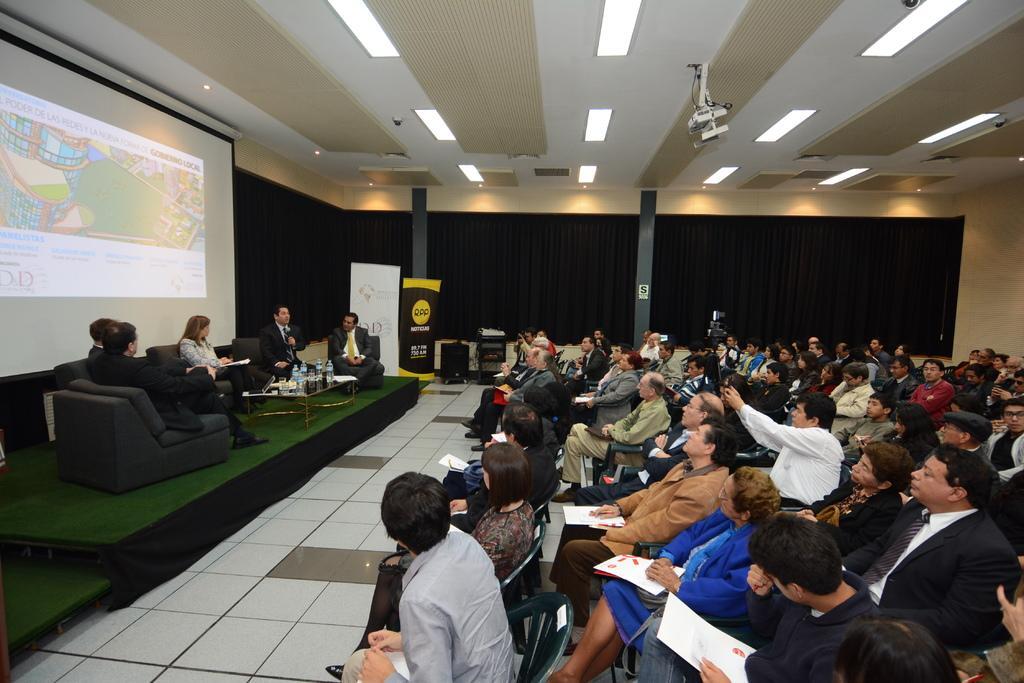Could you give a brief overview of what you see in this image? In this image people are sitting on chairs, in front of the people there is a stage, on that stage five persons are sitting on chairs in front of them there is a table on that table there are bottles, in the background there is a wall to that wall there is a black curtain and a projection of a screen at the top there is ceiling and lights. 